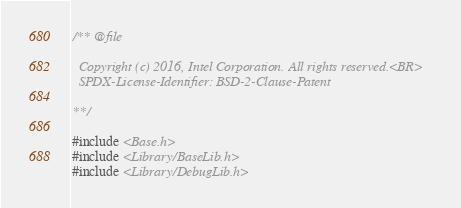<code> <loc_0><loc_0><loc_500><loc_500><_C_>/** @file

  Copyright (c) 2016, Intel Corporation. All rights reserved.<BR>
  SPDX-License-Identifier: BSD-2-Clause-Patent

**/

#include <Base.h>
#include <Library/BaseLib.h>
#include <Library/DebugLib.h>
</code> 